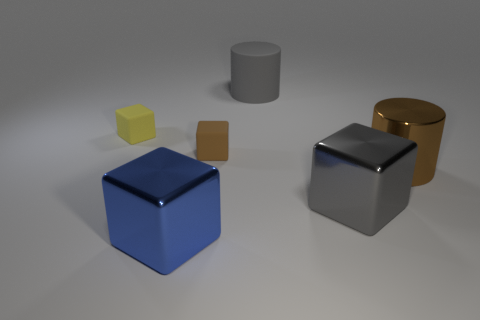Do the objects in the image have any textures or are they completely smooth? The objects appear mostly smooth, with what seems to be very subtle texturing, if any. The smoothness accentuates the clean geometric quality and allows the reflections and light to manifest clearly on their surfaces. 
What could be inferred about the size of these objects? The relative sizes of objects imply a varied scale, with smaller cubes up to a larger cylinder, suggesting a range that could be from a few centimeters to potentially tens of centimeters in height, but without a reference point in the image, the exact size remains speculative. 